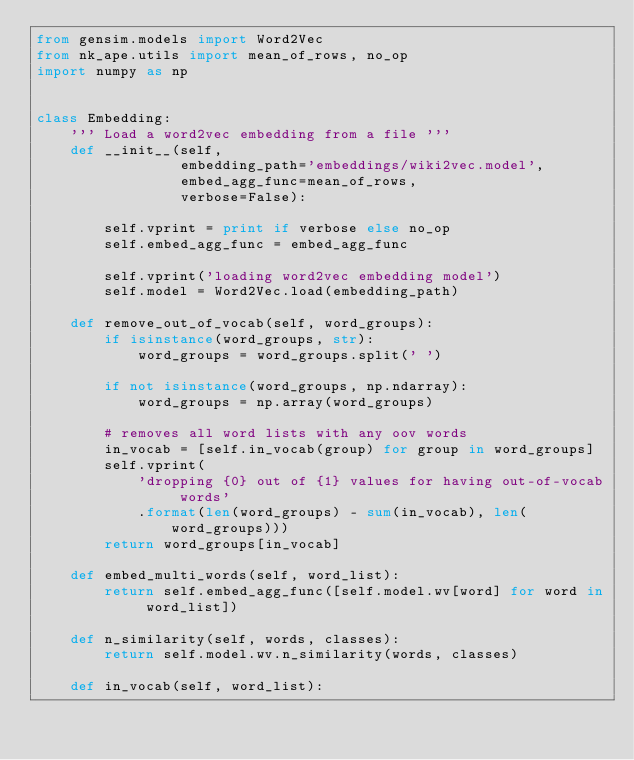<code> <loc_0><loc_0><loc_500><loc_500><_Python_>from gensim.models import Word2Vec
from nk_ape.utils import mean_of_rows, no_op
import numpy as np


class Embedding:
    ''' Load a word2vec embedding from a file '''
    def __init__(self,
                 embedding_path='embeddings/wiki2vec.model',
                 embed_agg_func=mean_of_rows,
                 verbose=False):

        self.vprint = print if verbose else no_op
        self.embed_agg_func = embed_agg_func

        self.vprint('loading word2vec embedding model')
        self.model = Word2Vec.load(embedding_path)

    def remove_out_of_vocab(self, word_groups):
        if isinstance(word_groups, str):
            word_groups = word_groups.split(' ')

        if not isinstance(word_groups, np.ndarray):
            word_groups = np.array(word_groups)

        # removes all word lists with any oov words
        in_vocab = [self.in_vocab(group) for group in word_groups]
        self.vprint(
            'dropping {0} out of {1} values for having out-of-vocab words'
            .format(len(word_groups) - sum(in_vocab), len(word_groups)))
        return word_groups[in_vocab]

    def embed_multi_words(self, word_list):
        return self.embed_agg_func([self.model.wv[word] for word in word_list])

    def n_similarity(self, words, classes):
        return self.model.wv.n_similarity(words, classes)

    def in_vocab(self, word_list):</code> 